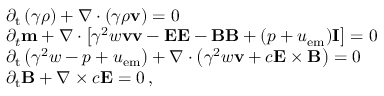Convert formula to latex. <formula><loc_0><loc_0><loc_500><loc_500>\begin{array} { r l } & { \partial _ { t } \left ( \gamma \rho \right ) + \nabla \cdot \left ( \gamma \rho v \right ) = 0 } \\ & { \partial _ { t } m + \nabla \cdot \left [ \gamma ^ { 2 } w v v - E E - B B + ( p + u _ { e m } ) I \right ] = 0 } \\ & { \partial _ { t } \left ( \gamma ^ { 2 } w - p + u _ { e m } \right ) + \nabla \cdot \left ( \gamma ^ { 2 } w v + c E \times B \right ) = 0 } \\ & { \partial _ { t } B + \nabla \times c E = 0 \, , } \end{array}</formula> 